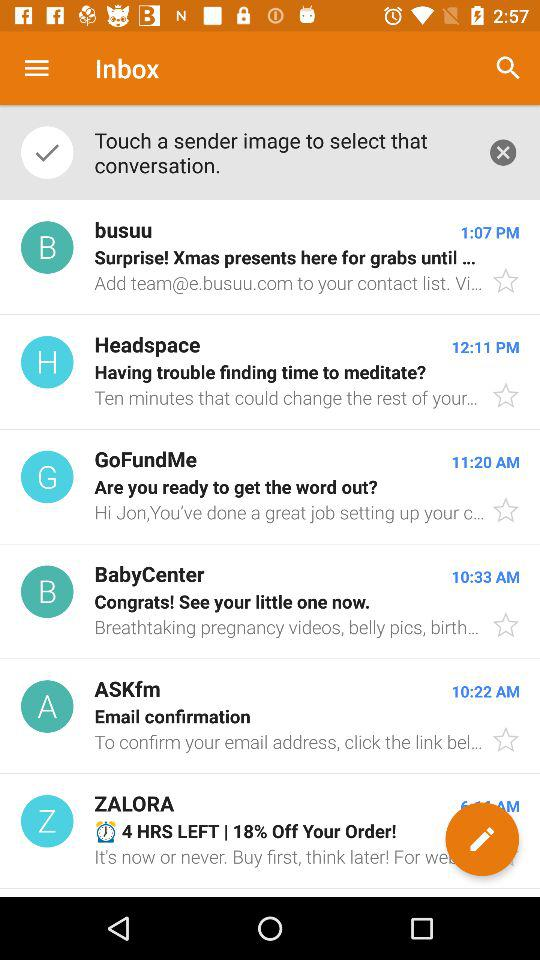What time did Headspace's email arrive? Headspace's email arrived at 12:11 PM. 